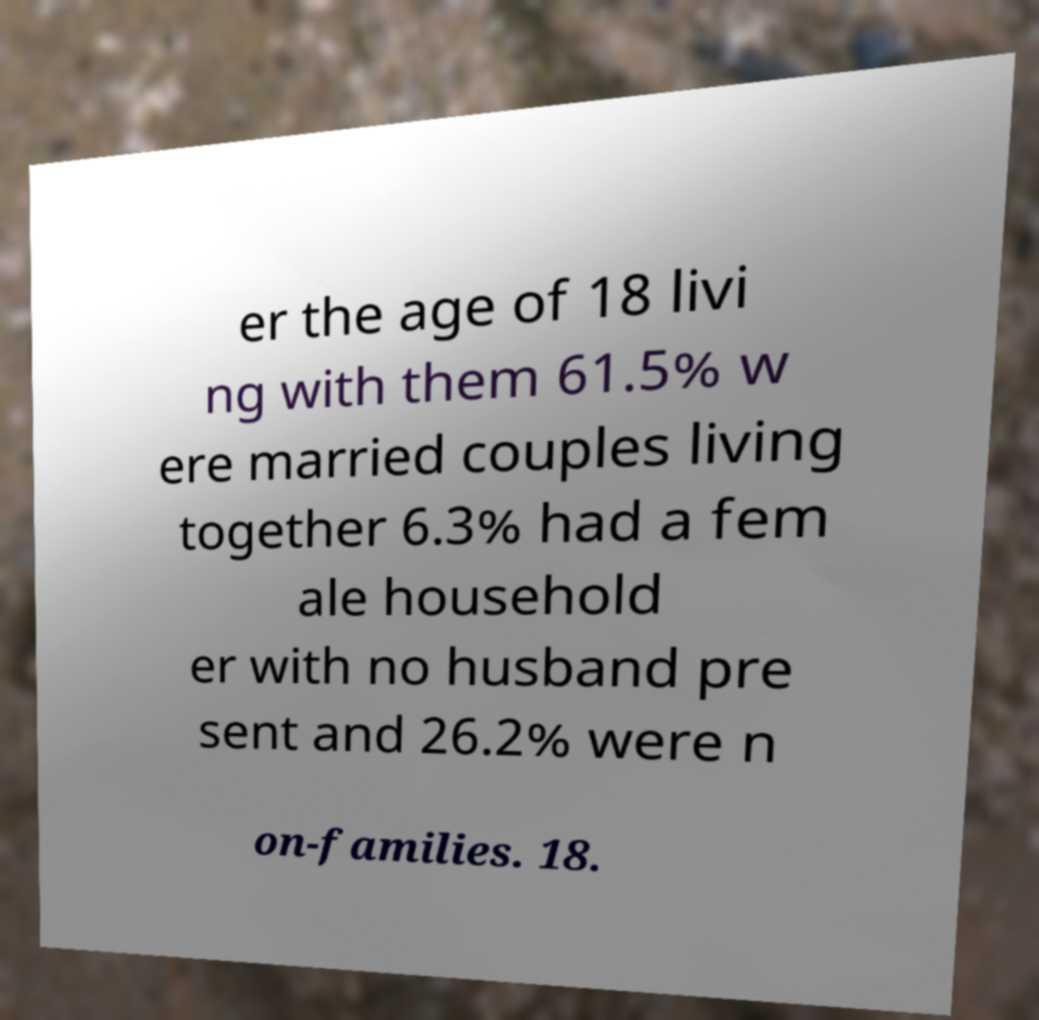I need the written content from this picture converted into text. Can you do that? er the age of 18 livi ng with them 61.5% w ere married couples living together 6.3% had a fem ale household er with no husband pre sent and 26.2% were n on-families. 18. 